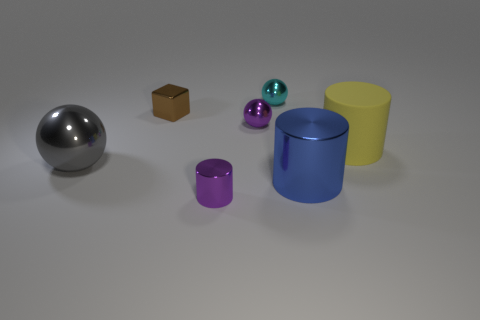Which objects have a reflective surface? The sphere on the left presents a reflective surface, as indicated by the visible highlights and the mirroring of the environment on its surface. 